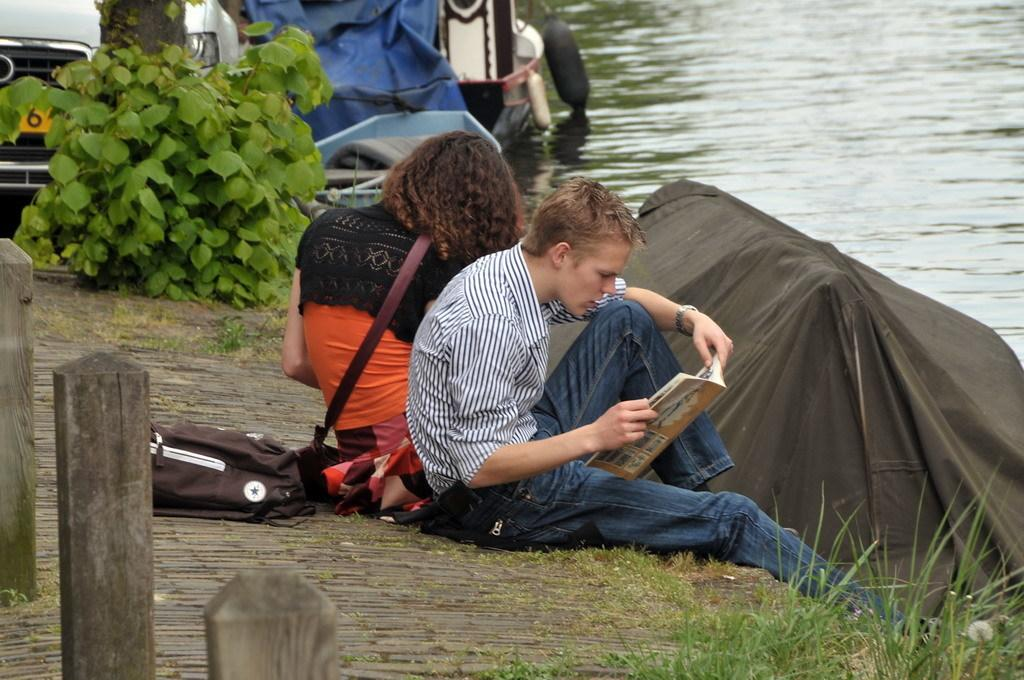What object can be seen in the image that is often used for carrying items? There is a bag in the image that is often used for carrying items. What item is visible in the image that is commonly used for reading or learning? There is a book in the image that is commonly used for reading or learning. How many people are sitting on the platform in the image? There are two people sitting on a platform in the image. What type of living organisms can be seen in the image? Plants are visible in the image. What type of vehicle is present in the image? There is a car in the image. What can be seen in the background of the image that is typically used for transportation on water? Boats are visible in the background of the image. What natural feature is visible in the background of the image? Water is visible in the background of the image. How many eggs are visible in the image, and what color are they in the image? There are no eggs visible in the image. What type of cub is playing with the book in the image? There is no cub present in the image, and therefore no such activity can be observed. 